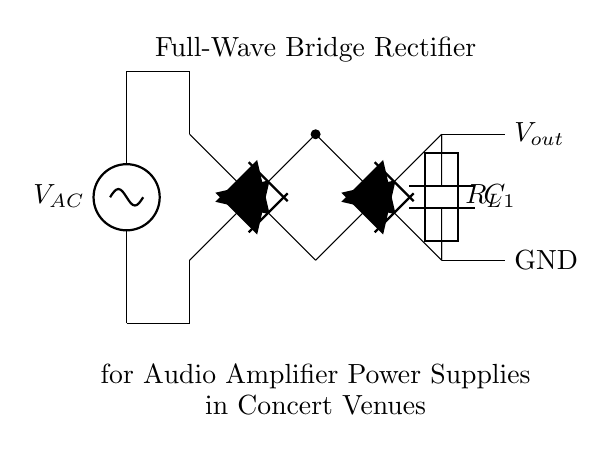What type of rectifier is depicted? The diagram illustrates a full-wave bridge rectifier, evident from the arrangement of four diodes configured to allow current to flow during both halves of the AC cycle.
Answer: full-wave bridge rectifier How many diodes are used in this rectifier? The circuit employs four diodes; two conduct during the positive half-cycle, and two during the negative half-cycle, enabling full-wave rectification.
Answer: four diodes What is represented by C1 in the circuit? C1 refers to a smoothing capacitor, which functions to reduce ripple voltage and provide a more stable DC output to the load resistor by storing charge.
Answer: smoothing capacitor What component is used as a load in the circuit? The load in this circuit is represented by R_L, which dissipates power in the form of heat and represents the device being powered by the rectifier's output.
Answer: load resistor Why is a full-wave bridge rectifier preferred for audio amplifier power supplies? A full-wave bridge rectifier is preferred because it provides greater efficiency by utilizing both halves of the input AC cycle and produces a smoother output, which is crucial for audio applications where distortion must be minimized.
Answer: greater efficiency What is the purpose of the AC voltage source in this configuration? The AC voltage source provides the necessary input electrical energy to the rectifier circuit, which is transformed into a usable DC voltage for the audio amplifier power supply.
Answer: input electrical energy 